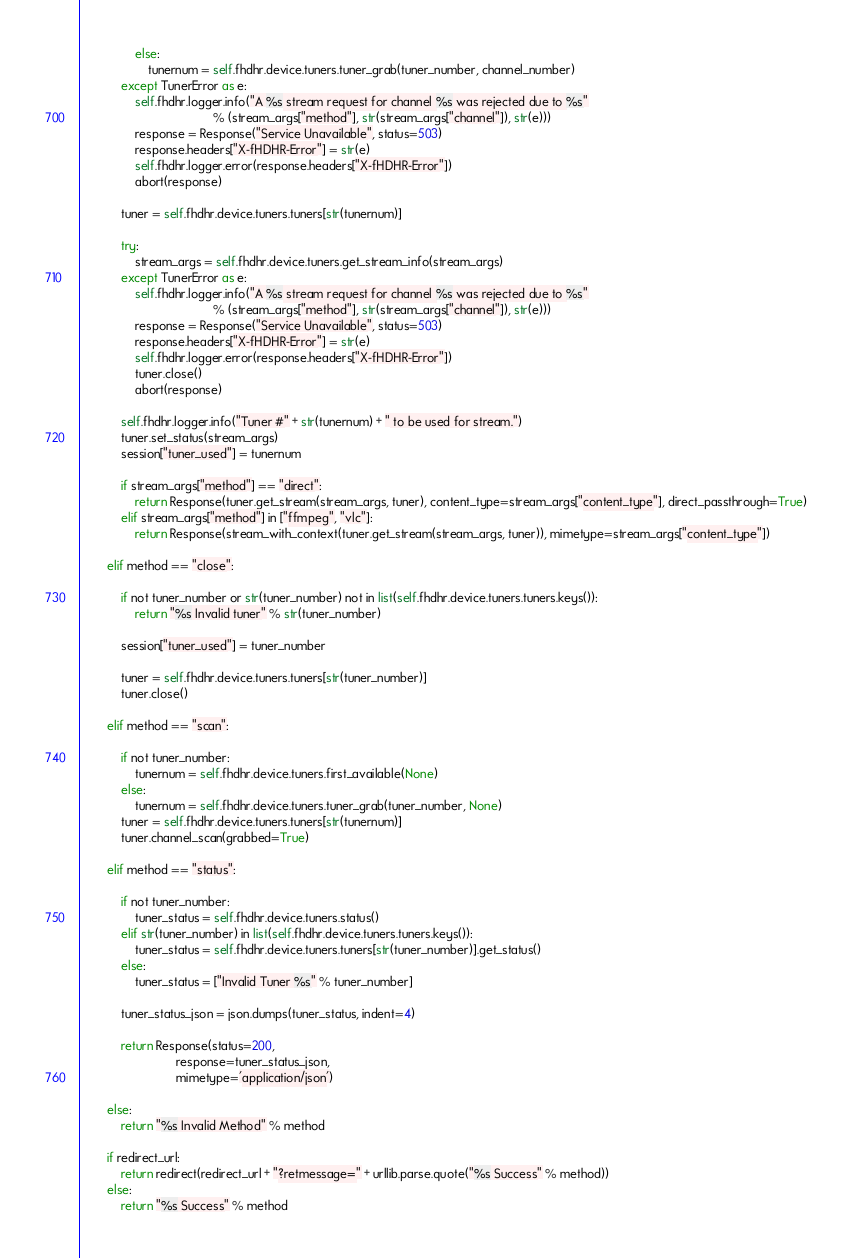<code> <loc_0><loc_0><loc_500><loc_500><_Python_>                else:
                    tunernum = self.fhdhr.device.tuners.tuner_grab(tuner_number, channel_number)
            except TunerError as e:
                self.fhdhr.logger.info("A %s stream request for channel %s was rejected due to %s"
                                       % (stream_args["method"], str(stream_args["channel"]), str(e)))
                response = Response("Service Unavailable", status=503)
                response.headers["X-fHDHR-Error"] = str(e)
                self.fhdhr.logger.error(response.headers["X-fHDHR-Error"])
                abort(response)

            tuner = self.fhdhr.device.tuners.tuners[str(tunernum)]

            try:
                stream_args = self.fhdhr.device.tuners.get_stream_info(stream_args)
            except TunerError as e:
                self.fhdhr.logger.info("A %s stream request for channel %s was rejected due to %s"
                                       % (stream_args["method"], str(stream_args["channel"]), str(e)))
                response = Response("Service Unavailable", status=503)
                response.headers["X-fHDHR-Error"] = str(e)
                self.fhdhr.logger.error(response.headers["X-fHDHR-Error"])
                tuner.close()
                abort(response)

            self.fhdhr.logger.info("Tuner #" + str(tunernum) + " to be used for stream.")
            tuner.set_status(stream_args)
            session["tuner_used"] = tunernum

            if stream_args["method"] == "direct":
                return Response(tuner.get_stream(stream_args, tuner), content_type=stream_args["content_type"], direct_passthrough=True)
            elif stream_args["method"] in ["ffmpeg", "vlc"]:
                return Response(stream_with_context(tuner.get_stream(stream_args, tuner)), mimetype=stream_args["content_type"])

        elif method == "close":

            if not tuner_number or str(tuner_number) not in list(self.fhdhr.device.tuners.tuners.keys()):
                return "%s Invalid tuner" % str(tuner_number)

            session["tuner_used"] = tuner_number

            tuner = self.fhdhr.device.tuners.tuners[str(tuner_number)]
            tuner.close()

        elif method == "scan":

            if not tuner_number:
                tunernum = self.fhdhr.device.tuners.first_available(None)
            else:
                tunernum = self.fhdhr.device.tuners.tuner_grab(tuner_number, None)
            tuner = self.fhdhr.device.tuners.tuners[str(tunernum)]
            tuner.channel_scan(grabbed=True)

        elif method == "status":

            if not tuner_number:
                tuner_status = self.fhdhr.device.tuners.status()
            elif str(tuner_number) in list(self.fhdhr.device.tuners.tuners.keys()):
                tuner_status = self.fhdhr.device.tuners.tuners[str(tuner_number)].get_status()
            else:
                tuner_status = ["Invalid Tuner %s" % tuner_number]

            tuner_status_json = json.dumps(tuner_status, indent=4)

            return Response(status=200,
                            response=tuner_status_json,
                            mimetype='application/json')

        else:
            return "%s Invalid Method" % method

        if redirect_url:
            return redirect(redirect_url + "?retmessage=" + urllib.parse.quote("%s Success" % method))
        else:
            return "%s Success" % method
</code> 